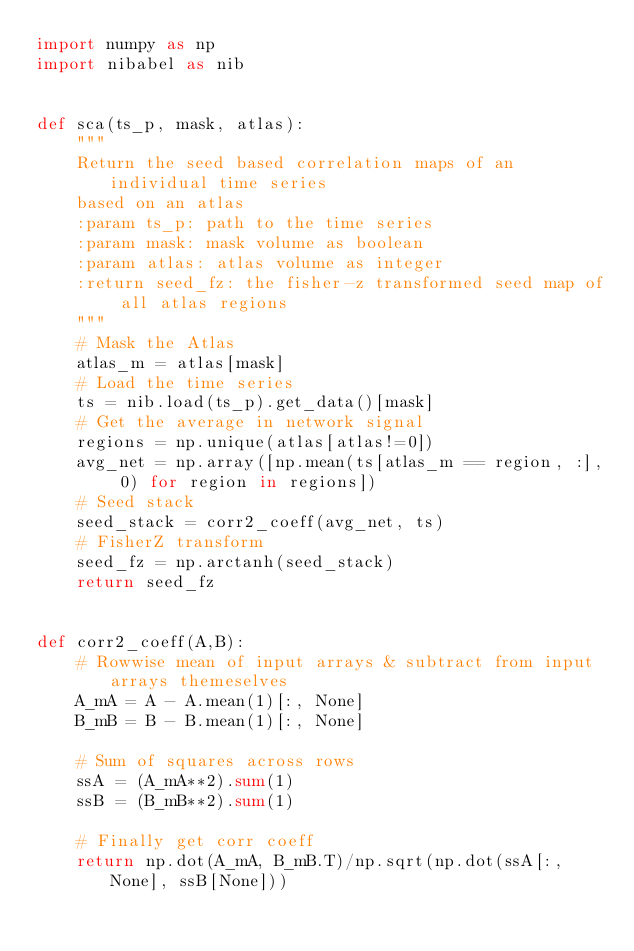Convert code to text. <code><loc_0><loc_0><loc_500><loc_500><_Python_>import numpy as np
import nibabel as nib


def sca(ts_p, mask, atlas):
    """
    Return the seed based correlation maps of an individual time series
    based on an atlas
    :param ts_p: path to the time series
    :param mask: mask volume as boolean
    :param atlas: atlas volume as integer
    :return seed_fz: the fisher-z transformed seed map of all atlas regions
    """
    # Mask the Atlas
    atlas_m = atlas[mask]
    # Load the time series
    ts = nib.load(ts_p).get_data()[mask]
    # Get the average in network signal
    regions = np.unique(atlas[atlas!=0])
    avg_net = np.array([np.mean(ts[atlas_m == region, :], 0) for region in regions])
    # Seed stack
    seed_stack = corr2_coeff(avg_net, ts)
    # FisherZ transform
    seed_fz = np.arctanh(seed_stack)
    return seed_fz


def corr2_coeff(A,B):
    # Rowwise mean of input arrays & subtract from input arrays themeselves
    A_mA = A - A.mean(1)[:, None]
    B_mB = B - B.mean(1)[:, None]

    # Sum of squares across rows
    ssA = (A_mA**2).sum(1)
    ssB = (B_mB**2).sum(1)

    # Finally get corr coeff
    return np.dot(A_mA, B_mB.T)/np.sqrt(np.dot(ssA[:, None], ssB[None]))
</code> 